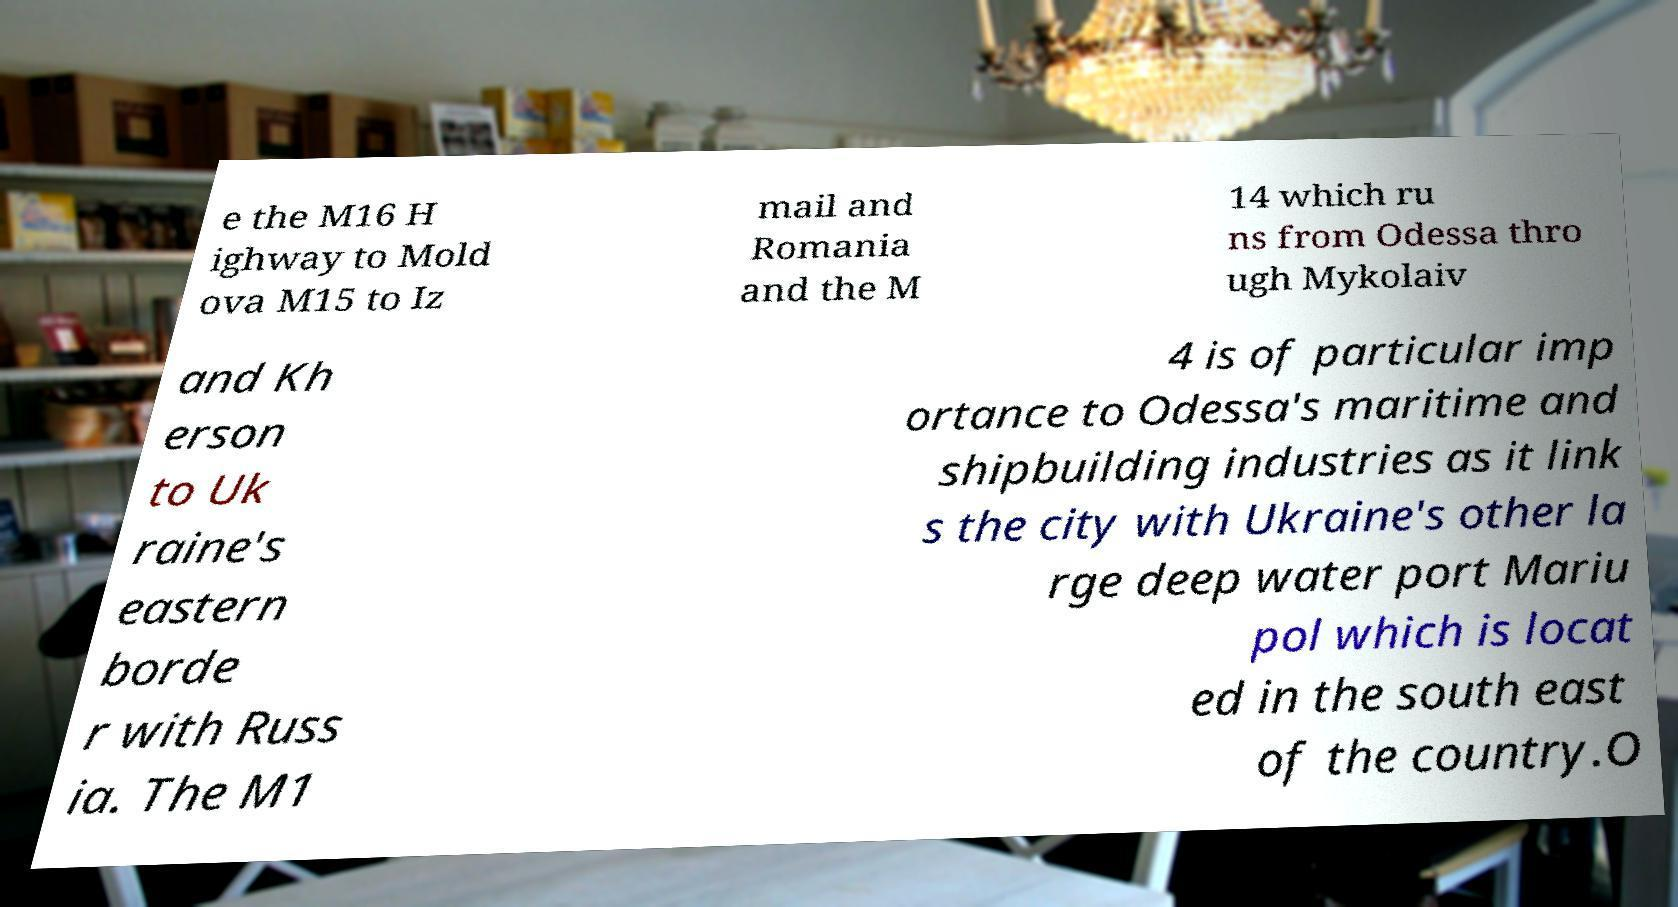Could you extract and type out the text from this image? e the M16 H ighway to Mold ova M15 to Iz mail and Romania and the M 14 which ru ns from Odessa thro ugh Mykolaiv and Kh erson to Uk raine's eastern borde r with Russ ia. The M1 4 is of particular imp ortance to Odessa's maritime and shipbuilding industries as it link s the city with Ukraine's other la rge deep water port Mariu pol which is locat ed in the south east of the country.O 